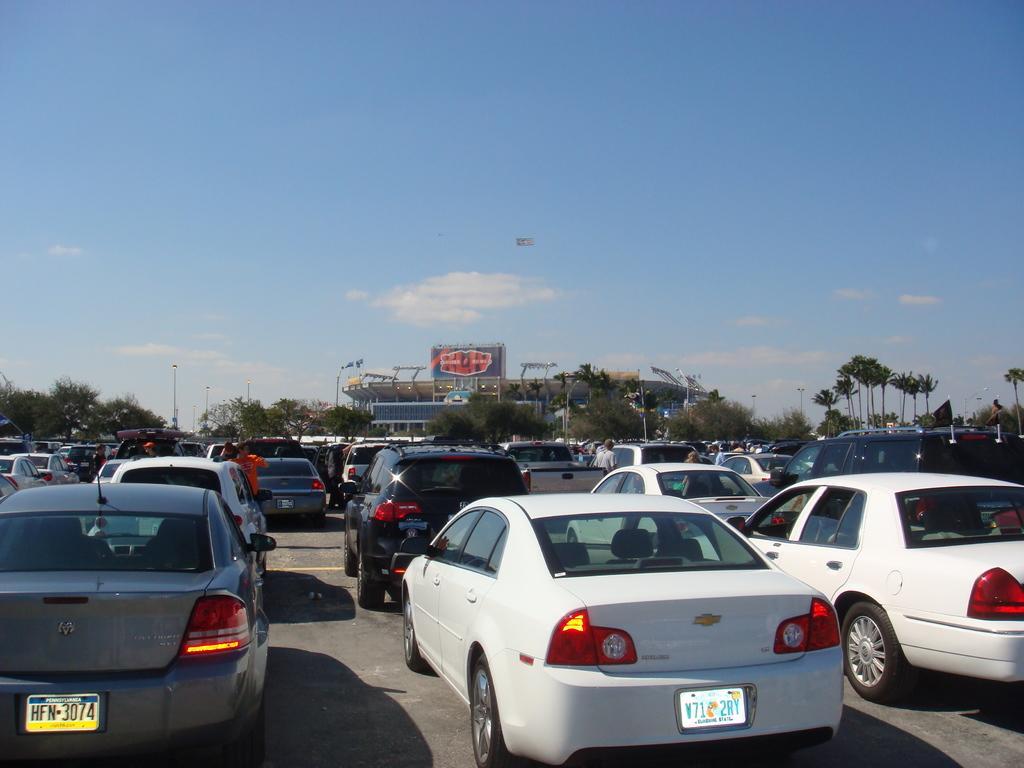Please provide a concise description of this image. In this image we can see some vehicles on the road and there are few people. In the background, we can see some trees and there is a building with a board and at the top we can see the sky with clouds. 